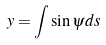<formula> <loc_0><loc_0><loc_500><loc_500>y = \int \sin \psi d s</formula> 